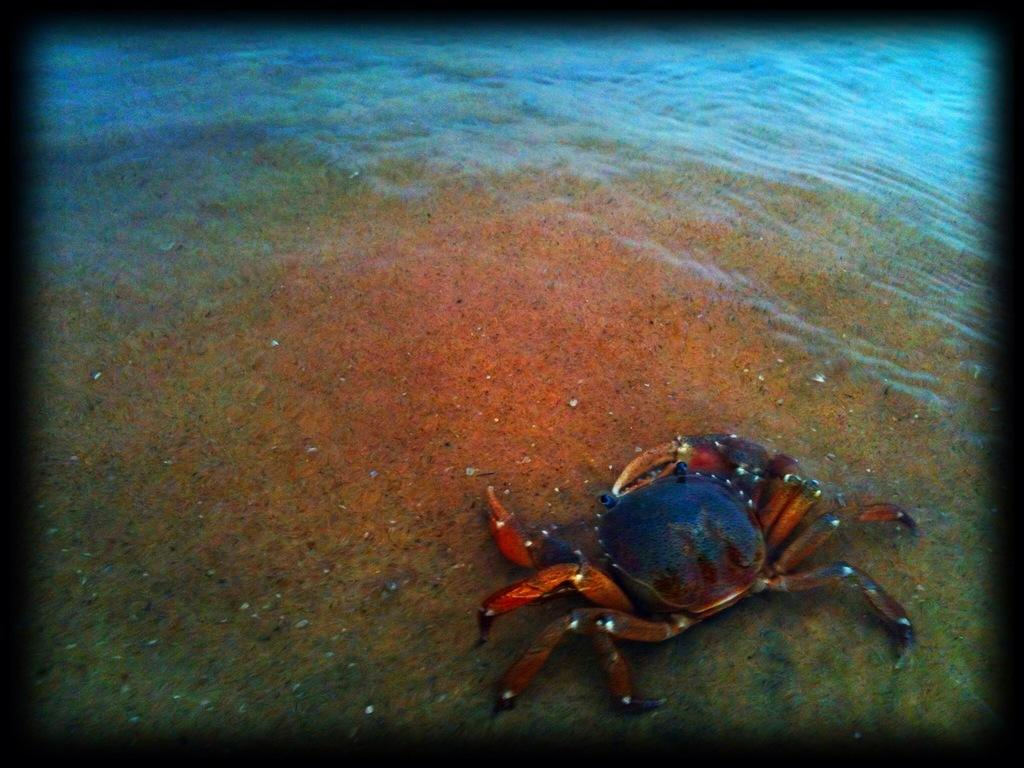What type of animal can be seen in the water in the image? There is a crab in the water in the image. What type of knee injury can be seen on the crab in the image? There is no indication of a knee injury on the crab in the image, as crabs do not have knees. 